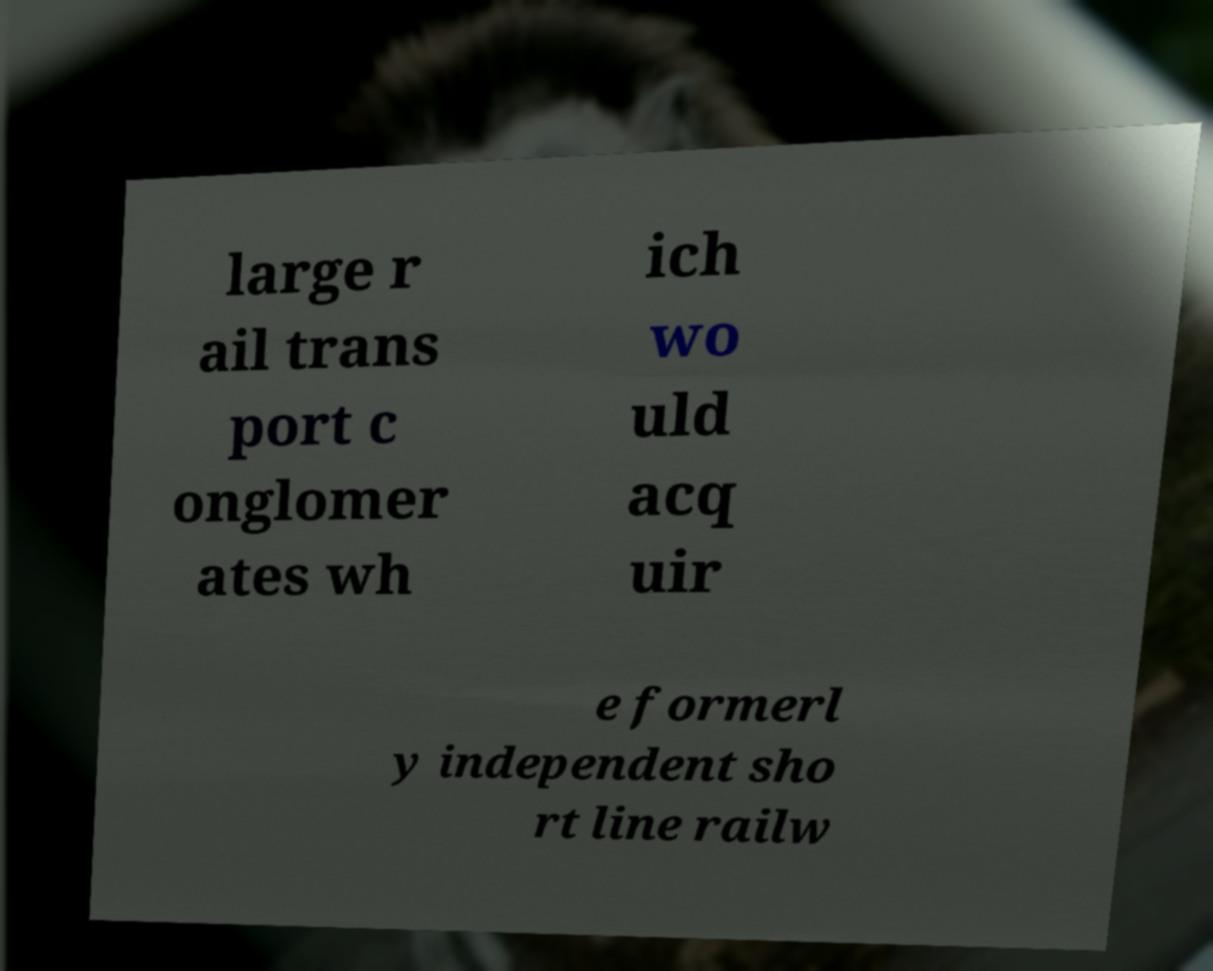What messages or text are displayed in this image? I need them in a readable, typed format. large r ail trans port c onglomer ates wh ich wo uld acq uir e formerl y independent sho rt line railw 